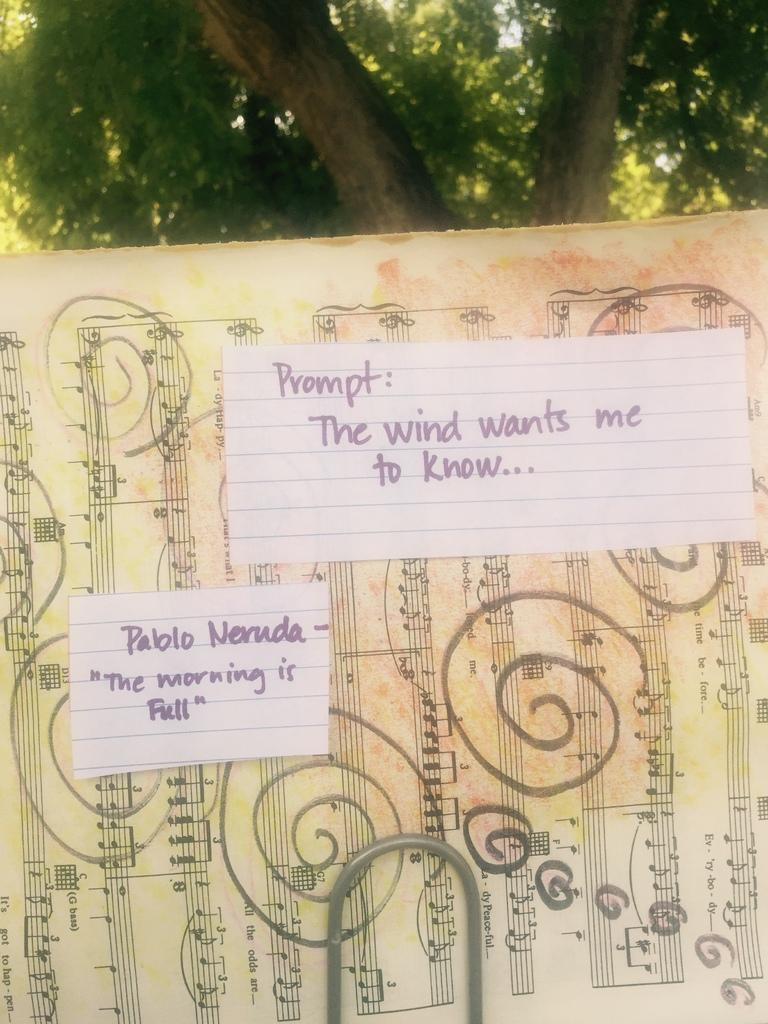What is the main object in the foreground of the image? There is a board in the foreground of the image. What can be seen on the board? There are music symbols and text on the board. What else is present in the foreground of the image? There is a rod in the foreground of the image. What can be seen in the background of the image? There is a tree in the background of the image. Can you see any ice forming on the tree in the background of the image? There is no ice visible on the tree in the image. What type of brush is being used to create the music symbols on the board? There is no brush present in the image; the music symbols are likely drawn or printed on the board. 